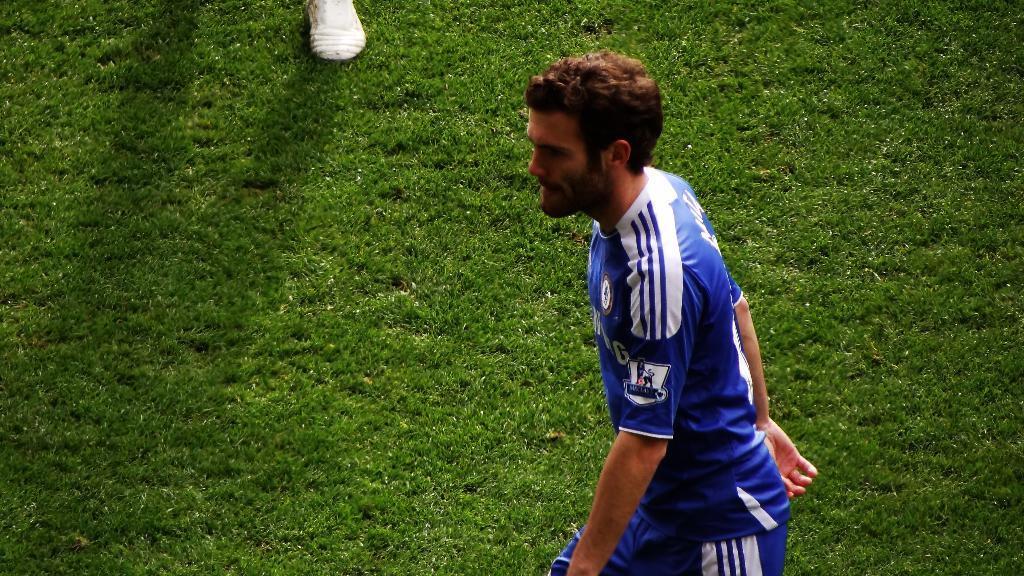Could you give a brief overview of what you see in this image? In this picture I can observe a man walking in the ground. There is some grass on the ground. Man is wearing blue color jersey. I can observe white color shoe on the top of the picture. 